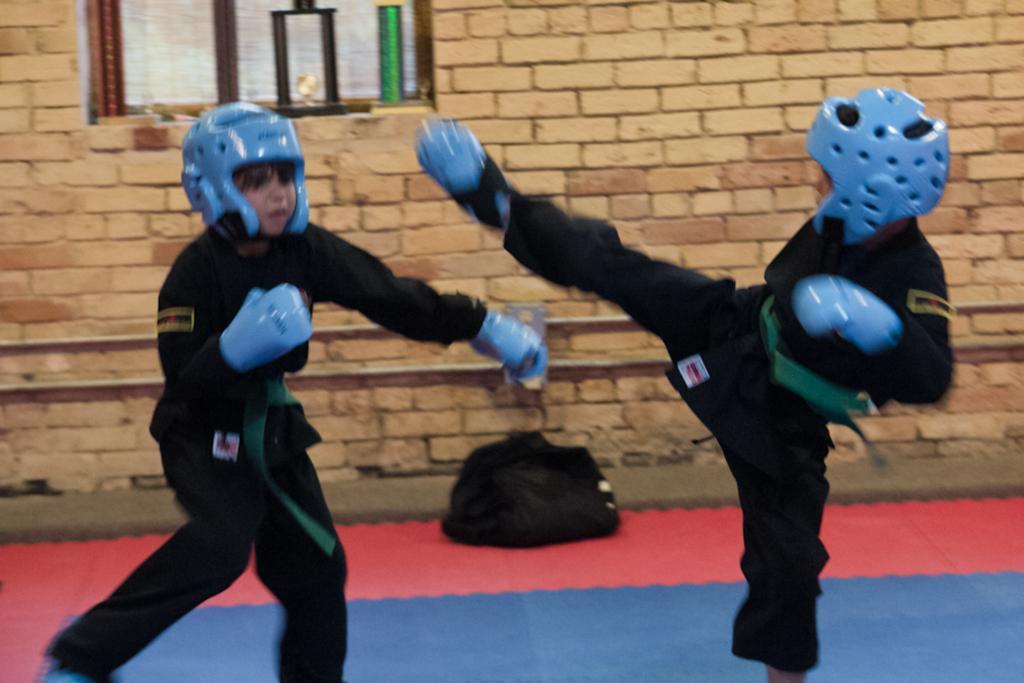Can you describe this image briefly? In this picture there is a kid wearing black dress and blue helmet raised one of his leg and there is another kid standing in front of him and there is a black bag,brick wall and some other objects in the background. 